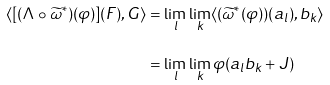Convert formula to latex. <formula><loc_0><loc_0><loc_500><loc_500>\langle [ ( \Lambda \circ \widetilde { \omega } ^ { * } ) ( \varphi ) ] ( F ) , G \rangle & = \lim _ { l } \lim _ { k } \langle ( \widetilde { \omega } ^ { * } ( \varphi ) ) ( a _ { l } ) , b _ { k } \rangle \\ & = \lim _ { l } \lim _ { k } \varphi ( a _ { l } b _ { k } + J )</formula> 